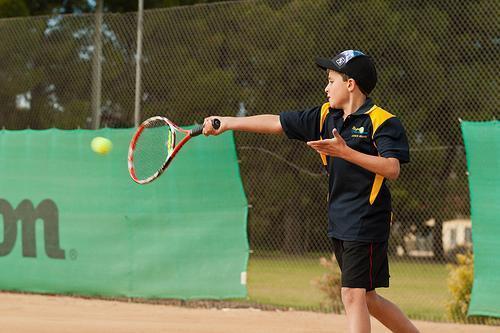How many people are there?
Give a very brief answer. 1. How many tennis balls are there?
Give a very brief answer. 1. 